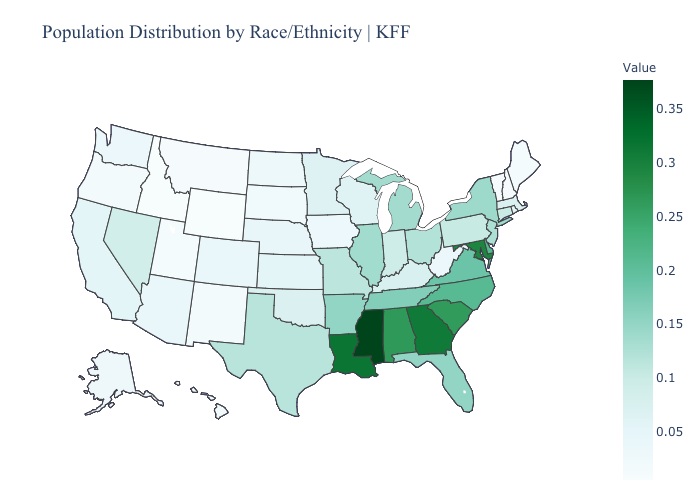Does Alabama have the highest value in the South?
Write a very short answer. No. Among the states that border Oregon , which have the highest value?
Concise answer only. Nevada. Does Iowa have the highest value in the USA?
Give a very brief answer. No. Which states have the lowest value in the USA?
Answer briefly. Idaho, Wyoming. Does the map have missing data?
Concise answer only. No. Which states hav the highest value in the West?
Concise answer only. Nevada. Is the legend a continuous bar?
Keep it brief. Yes. Does Rhode Island have the lowest value in the Northeast?
Short answer required. No. 